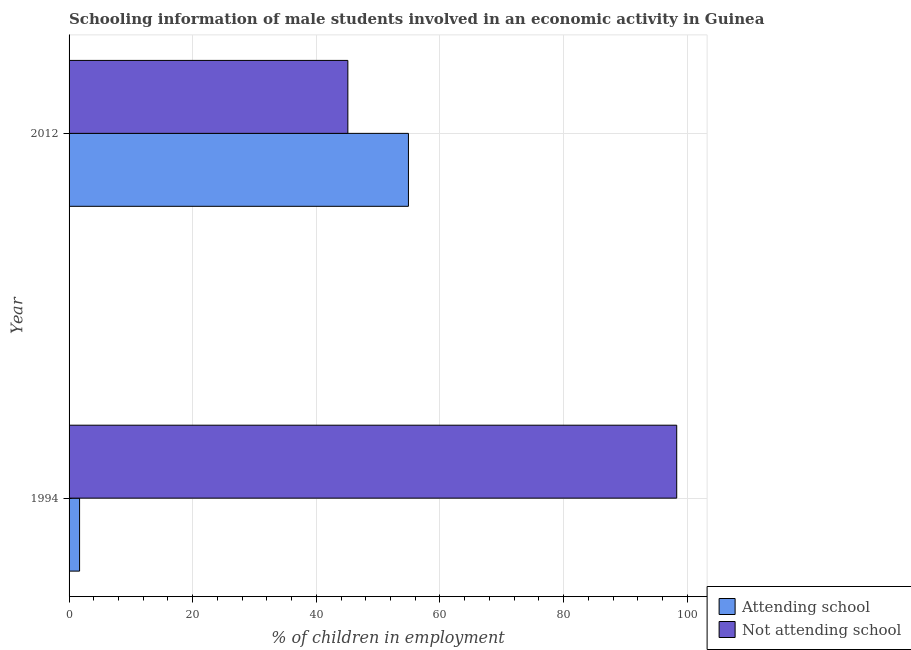How many different coloured bars are there?
Your answer should be compact. 2. How many bars are there on the 2nd tick from the top?
Make the answer very short. 2. How many bars are there on the 2nd tick from the bottom?
Your answer should be compact. 2. What is the label of the 1st group of bars from the top?
Make the answer very short. 2012. What is the percentage of employed males who are not attending school in 1994?
Your answer should be very brief. 98.3. Across all years, what is the maximum percentage of employed males who are not attending school?
Offer a very short reply. 98.3. Across all years, what is the minimum percentage of employed males who are not attending school?
Provide a short and direct response. 45.1. In which year was the percentage of employed males who are not attending school minimum?
Keep it short and to the point. 2012. What is the total percentage of employed males who are attending school in the graph?
Your answer should be compact. 56.6. What is the difference between the percentage of employed males who are attending school in 1994 and that in 2012?
Make the answer very short. -53.2. What is the difference between the percentage of employed males who are not attending school in 2012 and the percentage of employed males who are attending school in 1994?
Your answer should be compact. 43.4. What is the average percentage of employed males who are attending school per year?
Provide a short and direct response. 28.3. In the year 2012, what is the difference between the percentage of employed males who are not attending school and percentage of employed males who are attending school?
Keep it short and to the point. -9.8. What is the ratio of the percentage of employed males who are not attending school in 1994 to that in 2012?
Give a very brief answer. 2.18. Is the difference between the percentage of employed males who are not attending school in 1994 and 2012 greater than the difference between the percentage of employed males who are attending school in 1994 and 2012?
Provide a short and direct response. Yes. In how many years, is the percentage of employed males who are not attending school greater than the average percentage of employed males who are not attending school taken over all years?
Offer a terse response. 1. What does the 2nd bar from the top in 2012 represents?
Keep it short and to the point. Attending school. What does the 2nd bar from the bottom in 1994 represents?
Provide a succinct answer. Not attending school. How many bars are there?
Offer a very short reply. 4. How many years are there in the graph?
Provide a succinct answer. 2. Are the values on the major ticks of X-axis written in scientific E-notation?
Your answer should be compact. No. Does the graph contain any zero values?
Ensure brevity in your answer.  No. Does the graph contain grids?
Offer a very short reply. Yes. Where does the legend appear in the graph?
Your answer should be compact. Bottom right. What is the title of the graph?
Provide a short and direct response. Schooling information of male students involved in an economic activity in Guinea. Does "Death rate" appear as one of the legend labels in the graph?
Make the answer very short. No. What is the label or title of the X-axis?
Offer a very short reply. % of children in employment. What is the % of children in employment in Not attending school in 1994?
Your answer should be very brief. 98.3. What is the % of children in employment of Attending school in 2012?
Your answer should be compact. 54.9. What is the % of children in employment of Not attending school in 2012?
Keep it short and to the point. 45.1. Across all years, what is the maximum % of children in employment in Attending school?
Keep it short and to the point. 54.9. Across all years, what is the maximum % of children in employment in Not attending school?
Offer a very short reply. 98.3. Across all years, what is the minimum % of children in employment in Attending school?
Keep it short and to the point. 1.7. Across all years, what is the minimum % of children in employment in Not attending school?
Ensure brevity in your answer.  45.1. What is the total % of children in employment in Attending school in the graph?
Offer a very short reply. 56.6. What is the total % of children in employment in Not attending school in the graph?
Keep it short and to the point. 143.4. What is the difference between the % of children in employment of Attending school in 1994 and that in 2012?
Give a very brief answer. -53.2. What is the difference between the % of children in employment of Not attending school in 1994 and that in 2012?
Give a very brief answer. 53.2. What is the difference between the % of children in employment of Attending school in 1994 and the % of children in employment of Not attending school in 2012?
Offer a very short reply. -43.4. What is the average % of children in employment in Attending school per year?
Ensure brevity in your answer.  28.3. What is the average % of children in employment of Not attending school per year?
Ensure brevity in your answer.  71.7. In the year 1994, what is the difference between the % of children in employment in Attending school and % of children in employment in Not attending school?
Ensure brevity in your answer.  -96.6. What is the ratio of the % of children in employment in Attending school in 1994 to that in 2012?
Your answer should be very brief. 0.03. What is the ratio of the % of children in employment of Not attending school in 1994 to that in 2012?
Your answer should be compact. 2.18. What is the difference between the highest and the second highest % of children in employment in Attending school?
Make the answer very short. 53.2. What is the difference between the highest and the second highest % of children in employment of Not attending school?
Provide a short and direct response. 53.2. What is the difference between the highest and the lowest % of children in employment in Attending school?
Your answer should be very brief. 53.2. What is the difference between the highest and the lowest % of children in employment in Not attending school?
Your answer should be very brief. 53.2. 